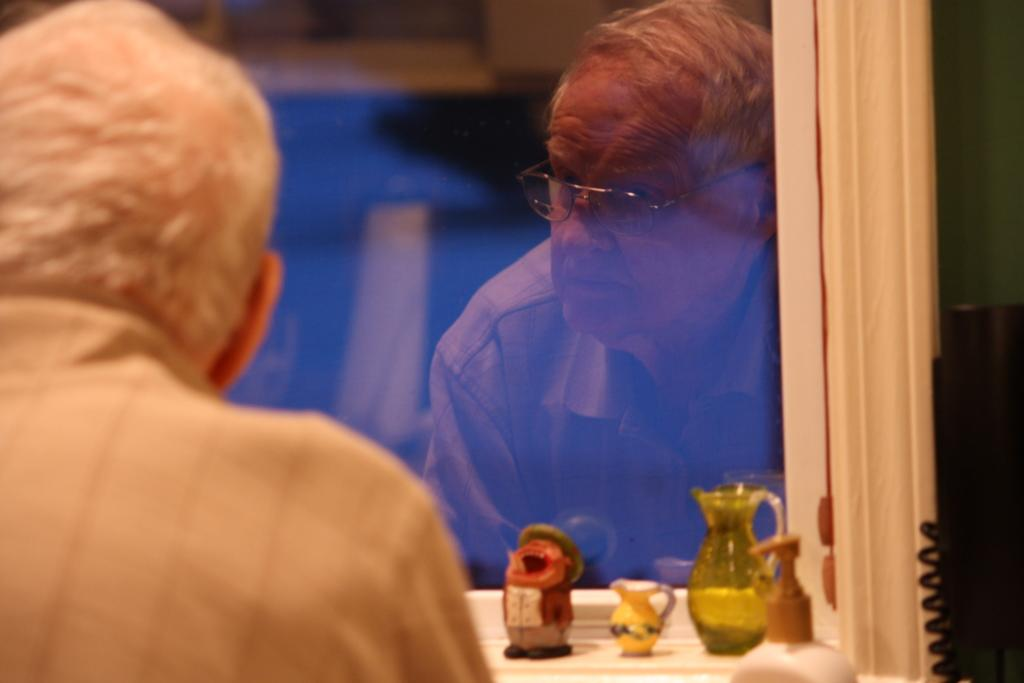Who or what is the main subject in the image? There is a person in the image. What is the person wearing? The person is wearing a brown shirt. What can be seen in the background of the image? There are objects visible in the background of the image. Can you describe any specific object in the image? Yes, there is a glass frame in the image. What type of jelly is being used to burn the person's shirt in the image? There is no jelly or burning depicted in the image; the person is simply wearing a brown shirt. 